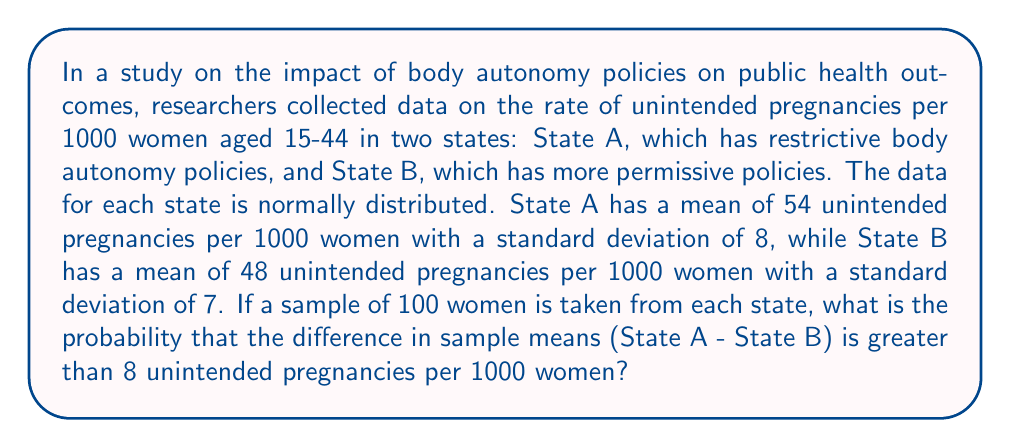What is the answer to this math problem? To solve this problem, we'll follow these steps:

1) First, we need to understand that we're dealing with the difference between two sample means. The sampling distribution of the difference between means is also normally distributed.

2) We need to calculate the mean and standard deviation of this sampling distribution:

   Mean of the difference = $\mu_A - \mu_B = 54 - 48 = 6$

   Standard deviation of the difference = $\sqrt{\frac{\sigma_A^2}{n_A} + \frac{\sigma_B^2}{n_B}}$
   
   Where $n_A = n_B = 100$

   $\sqrt{\frac{8^2}{100} + \frac{7^2}{100}} = \sqrt{\frac{64}{100} + \frac{49}{100}} = \sqrt{\frac{113}{100}} = 1.06$

3) Now, we want to find $P(\bar{X}_A - \bar{X}_B > 8)$

4) We can standardize this to a z-score:

   $z = \frac{8 - 6}{1.06} = 1.89$

5) We need to find $P(Z > 1.89)$

6) Using a standard normal table or calculator, we can find that:

   $P(Z > 1.89) = 1 - P(Z < 1.89) = 1 - 0.9706 = 0.0294$

Therefore, the probability that the difference in sample means is greater than 8 is approximately 0.0294 or 2.94%.
Answer: 0.0294 